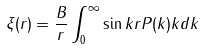Convert formula to latex. <formula><loc_0><loc_0><loc_500><loc_500>\xi ( r ) = \frac { B } { r } \int _ { 0 } ^ { \infty } \sin k r P ( k ) k d k</formula> 